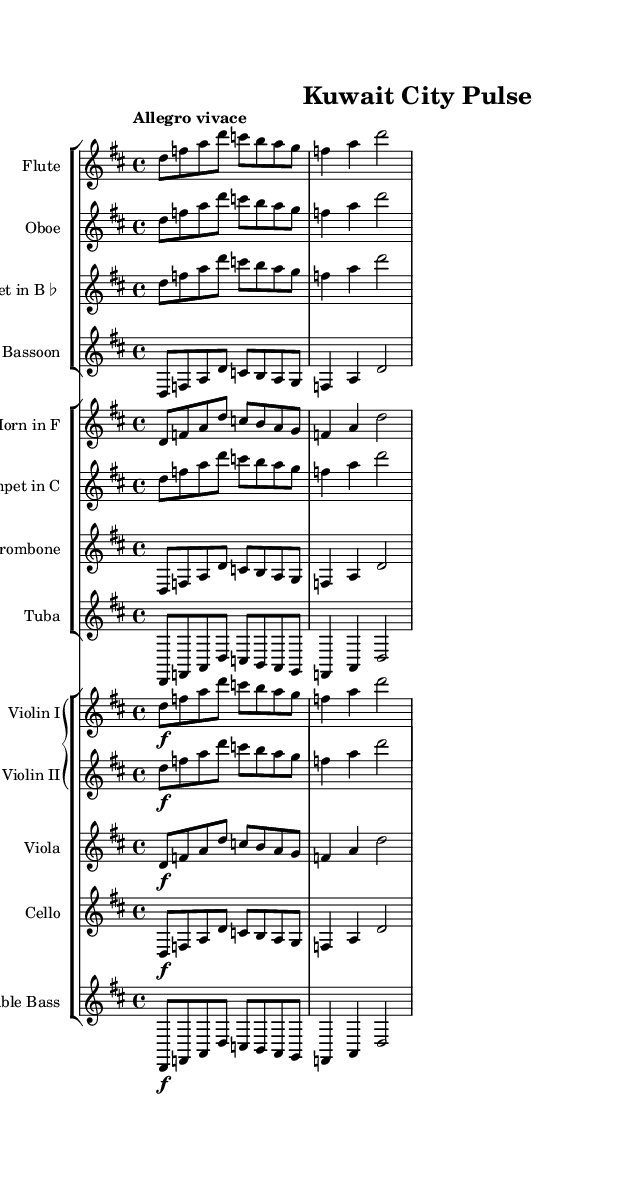What is the key signature of this music? The key signature is D major, indicated by the two sharps at the beginning of the staff.
Answer: D major What is the time signature of this music? The time signature is 4/4, shown at the beginning of the sheet music, which means there are four beats in a measure.
Answer: 4/4 What is the tempo marking for this symphony? The tempo marking is "Allegro vivace," which suggests a fast and lively pace for the performance.
Answer: Allegro vivace How many instruments are featured in this symphony? There are twelve instruments listed in the score, as seen in the organized groups of staves for woodwinds, brass, and strings.
Answer: Twelve Which instrument is transposed to B flat? The clarinet is transposed to B flat, indicated by the transposition marking next to the instrument name.
Answer: Clarinet What dynamic marking is used for the strings? The dynamic marking used for the strings is forte, indicated by the "f" symbol next to the notes in the violin and cello parts.
Answer: Forte Which instruments are grouped under the brass section? The brass section includes the horn, trumpet, trombone, and tuba, as represented by their respective staves in the score.
Answer: Horn, trumpet, trombone, tuba 